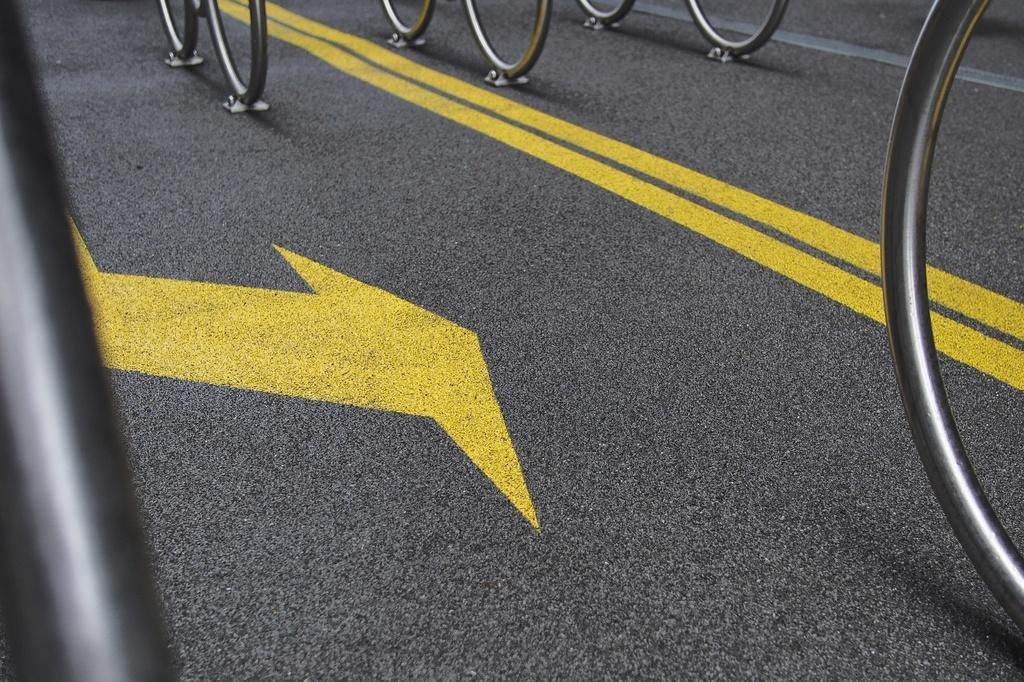What is the main feature of the image? There is a road in the image. Are there any objects on the road? Yes, metal rings are present on the road. Is there any signage on the road? Yes, there is a direction sign on the road. What type of pencil can be seen lying on the road in the image? There is no pencil present in the image; only the road, metal rings, and direction sign are visible. 